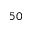<formula> <loc_0><loc_0><loc_500><loc_500>5 0</formula> 